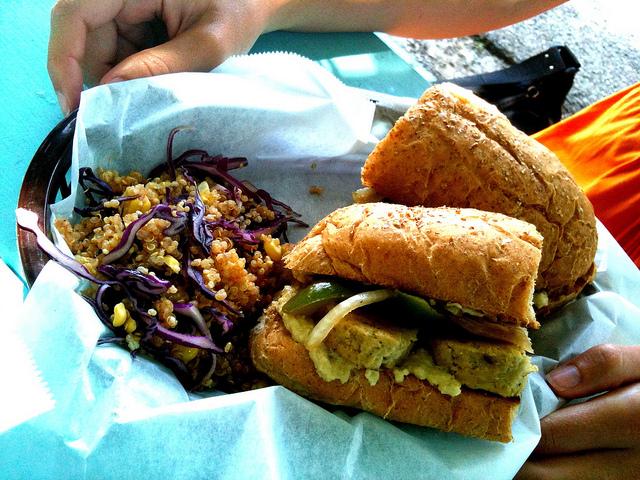What body part is visible in the photo?
Answer briefly. Hands. Is this from Burger King?
Quick response, please. No. Is there corn in this picture?
Concise answer only. Yes. 